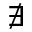Convert formula to latex. <formula><loc_0><loc_0><loc_500><loc_500>\nexists</formula> 